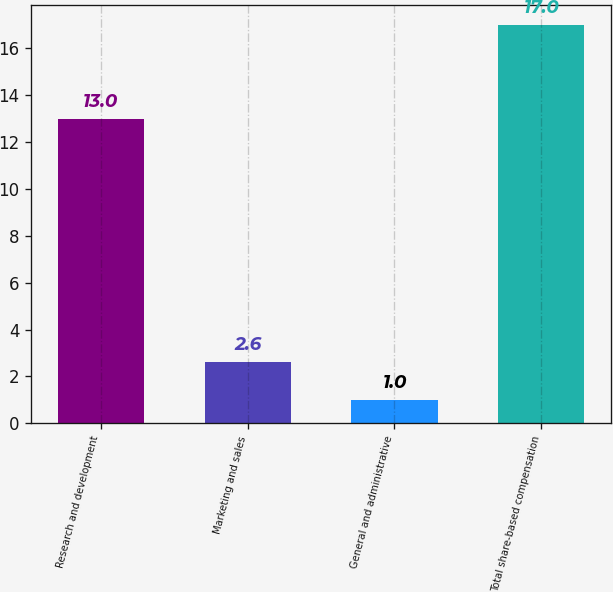<chart> <loc_0><loc_0><loc_500><loc_500><bar_chart><fcel>Research and development<fcel>Marketing and sales<fcel>General and administrative<fcel>Total share-based compensation<nl><fcel>13<fcel>2.6<fcel>1<fcel>17<nl></chart> 